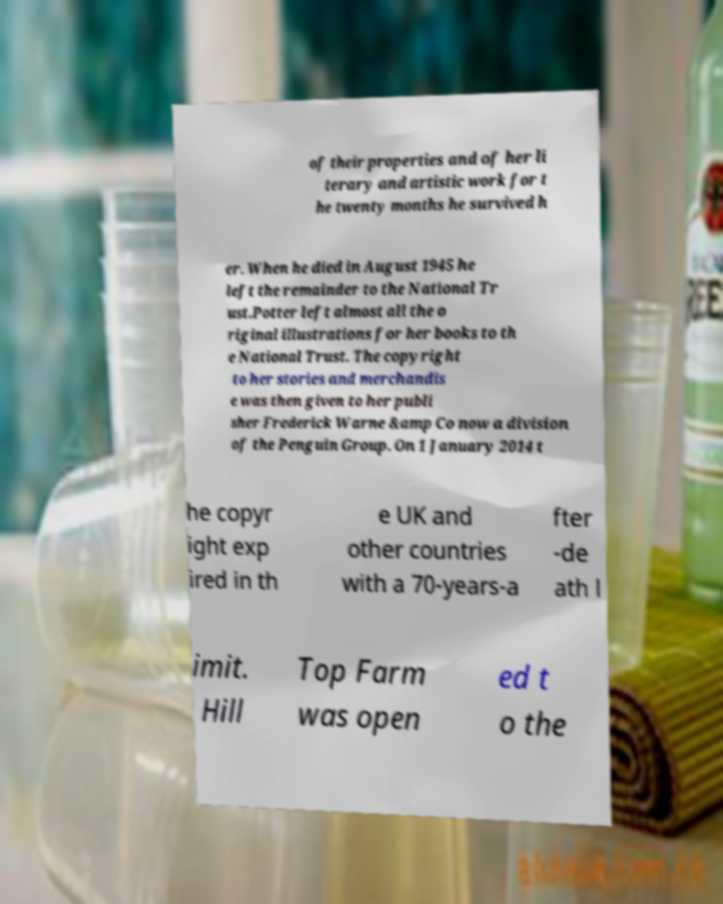Please read and relay the text visible in this image. What does it say? of their properties and of her li terary and artistic work for t he twenty months he survived h er. When he died in August 1945 he left the remainder to the National Tr ust.Potter left almost all the o riginal illustrations for her books to th e National Trust. The copyright to her stories and merchandis e was then given to her publi sher Frederick Warne &amp Co now a division of the Penguin Group. On 1 January 2014 t he copyr ight exp ired in th e UK and other countries with a 70-years-a fter -de ath l imit. Hill Top Farm was open ed t o the 